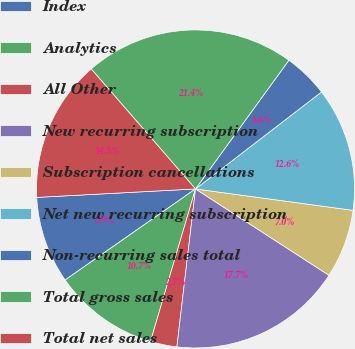Convert chart to OTSL. <chart><loc_0><loc_0><loc_500><loc_500><pie_chart><fcel>Index<fcel>Analytics<fcel>All Other<fcel>New recurring subscription<fcel>Subscription cancellations<fcel>Net new recurring subscription<fcel>Non-recurring sales total<fcel>Total gross sales<fcel>Total net sales<nl><fcel>8.86%<fcel>10.73%<fcel>2.7%<fcel>17.73%<fcel>6.99%<fcel>12.59%<fcel>4.57%<fcel>21.38%<fcel>14.46%<nl></chart> 